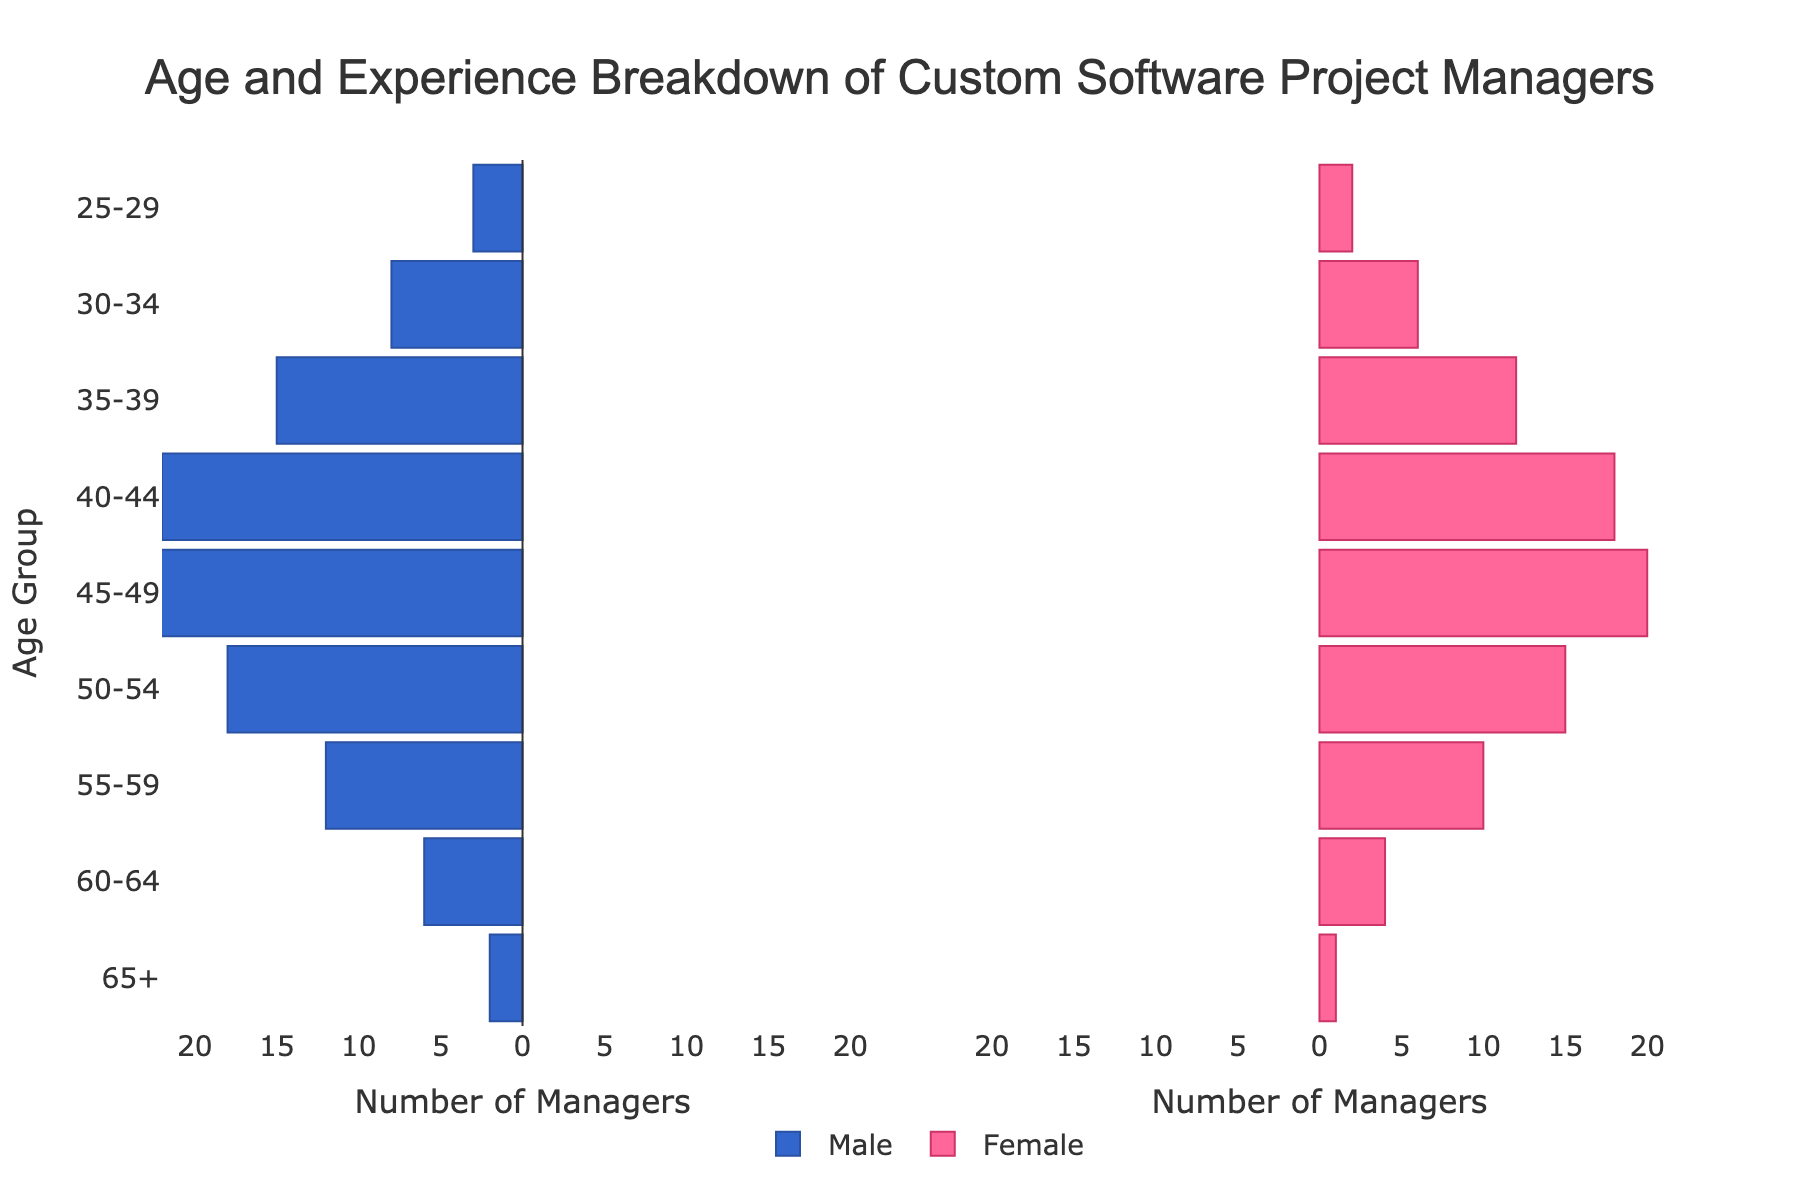How many age groups are displayed in the chart? The chart shows age groups on the y-axis, each group representing a range of 5 years except the last one. Counting all the age group labels on the left y-axis gives us the total number of age groups.
Answer: 9 Which age group has the highest number of male project managers? Look at the bars on the left side of the pyramid (colored in blue), and identify which age group has the longest bar. The age group 45-49 has the longest bar among males.
Answer: 45-49 What is the total number of female project managers in the 50-54 and 55-59 age groups combined? Look at the lengths of the bars corresponding to the female managers (colored in pink) for the age groups 50-54 and 55-59. The count is 15 for 50-54 and 10 for 55-59. Adding these numbers gives 15 + 10 = 25.
Answer: 25 How does the number of male project managers compare between the 35-39 and 65+ age groups? Compare the lengths of the bars colored in blue for the two age groups. The bar for 35-39 is longer than the bar for 65+, indicating a higher number of male project managers in the 35-39 age group. The exact numbers are 15 for 35-39 and 2 for 65+.
Answer: Male project managers are higher in 35-39 Which gender has a higher count in the 40-44 age group? For the 40-44 age group, compare the lengths of the male and female bars. The male bar (22) is longer than the female bar (18).
Answer: Male What is the average number of male managers across all age groups? Sum the number of male managers in all age groups (3 + 8 + 15 + 22 + 25 + 18 + 12 + 6 + 2 = 111). There are 9 age groups, so the average is 111/9.
Answer: 12.33 Is there an age group where the number of female project managers exceeds the number of male project managers? Compare the lengths of the male and female bars for each age group. In all age groups, male managers exceed female managers.
Answer: No What is the overall gender ratio of project managers? Sum the total number of male managers (111) and the total number of female managers (88). The ratio is 111:88 or approximately 1.26:1 in favor of male managers.
Answer: 1.26:1 Which age group has the smallest difference between the number of male and female project managers? Calculate the absolute difference between the male and female counts for each age group. The smallest difference is in the 55-59 age group with a difference of 2 (12 - 10).
Answer: 55-59 